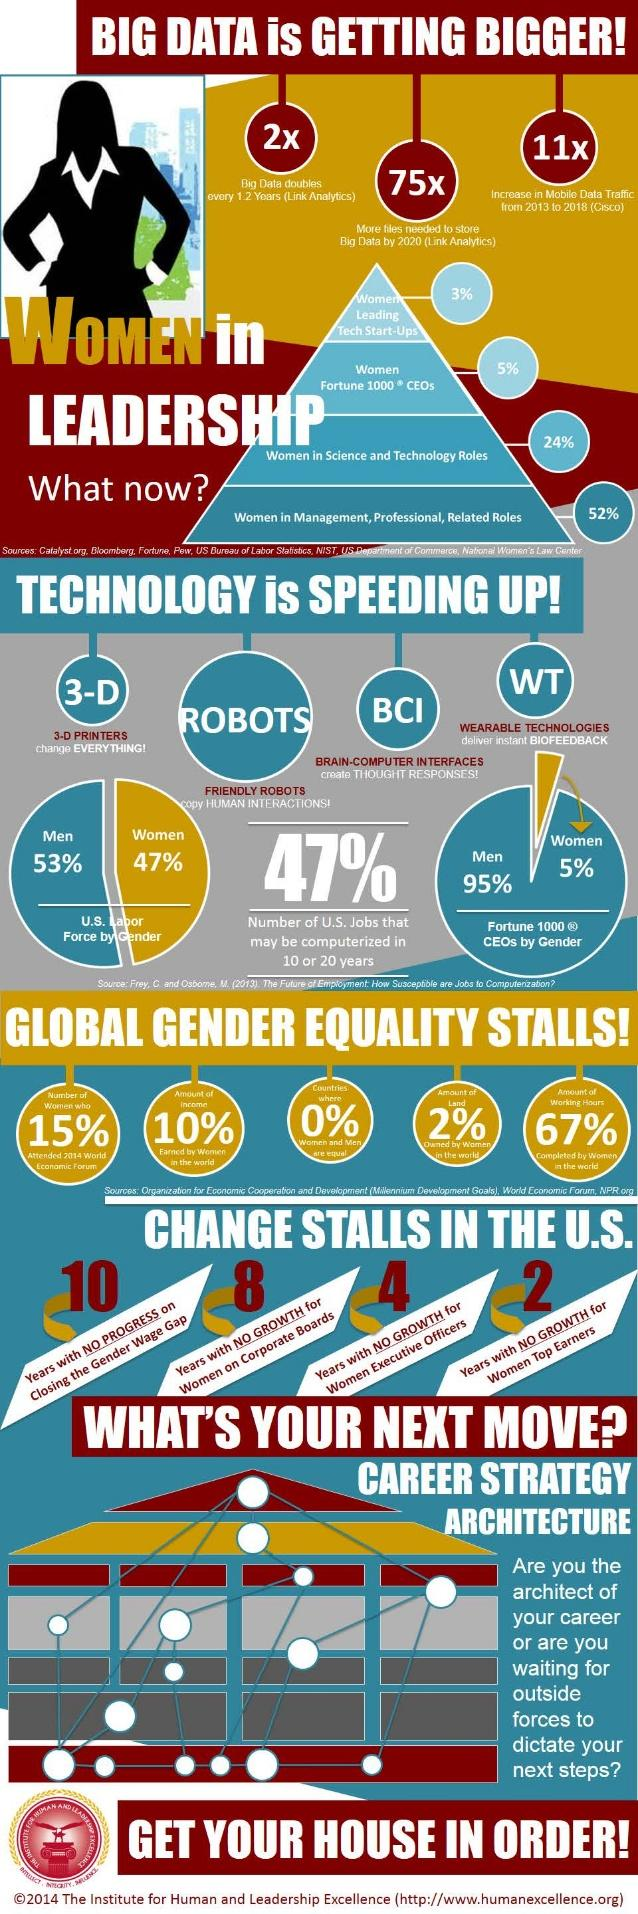Specify some key components in this picture. According to recent studies, only 3% of women are leading tech startups globally. According to recent statistics, approximately 47% of the U.S. labor force is composed of women. Only 2% of the world's land is owned by women. There is zero percent of the countries in the world that treat both men and women as equals. According to the data, 24% of the women are employed in Science and Technology roles. 